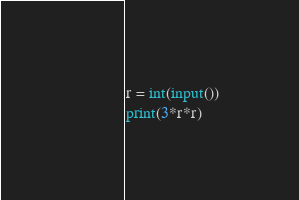Convert code to text. <code><loc_0><loc_0><loc_500><loc_500><_Python_>r = int(input())
print(3*r*r)</code> 